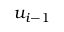<formula> <loc_0><loc_0><loc_500><loc_500>u _ { i - 1 }</formula> 